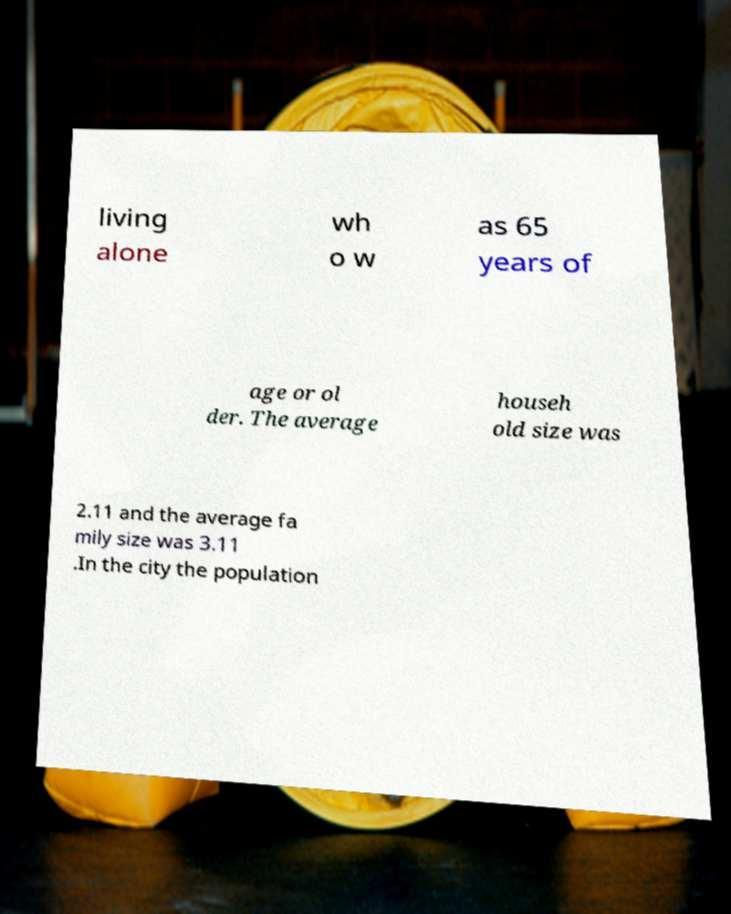For documentation purposes, I need the text within this image transcribed. Could you provide that? living alone wh o w as 65 years of age or ol der. The average househ old size was 2.11 and the average fa mily size was 3.11 .In the city the population 